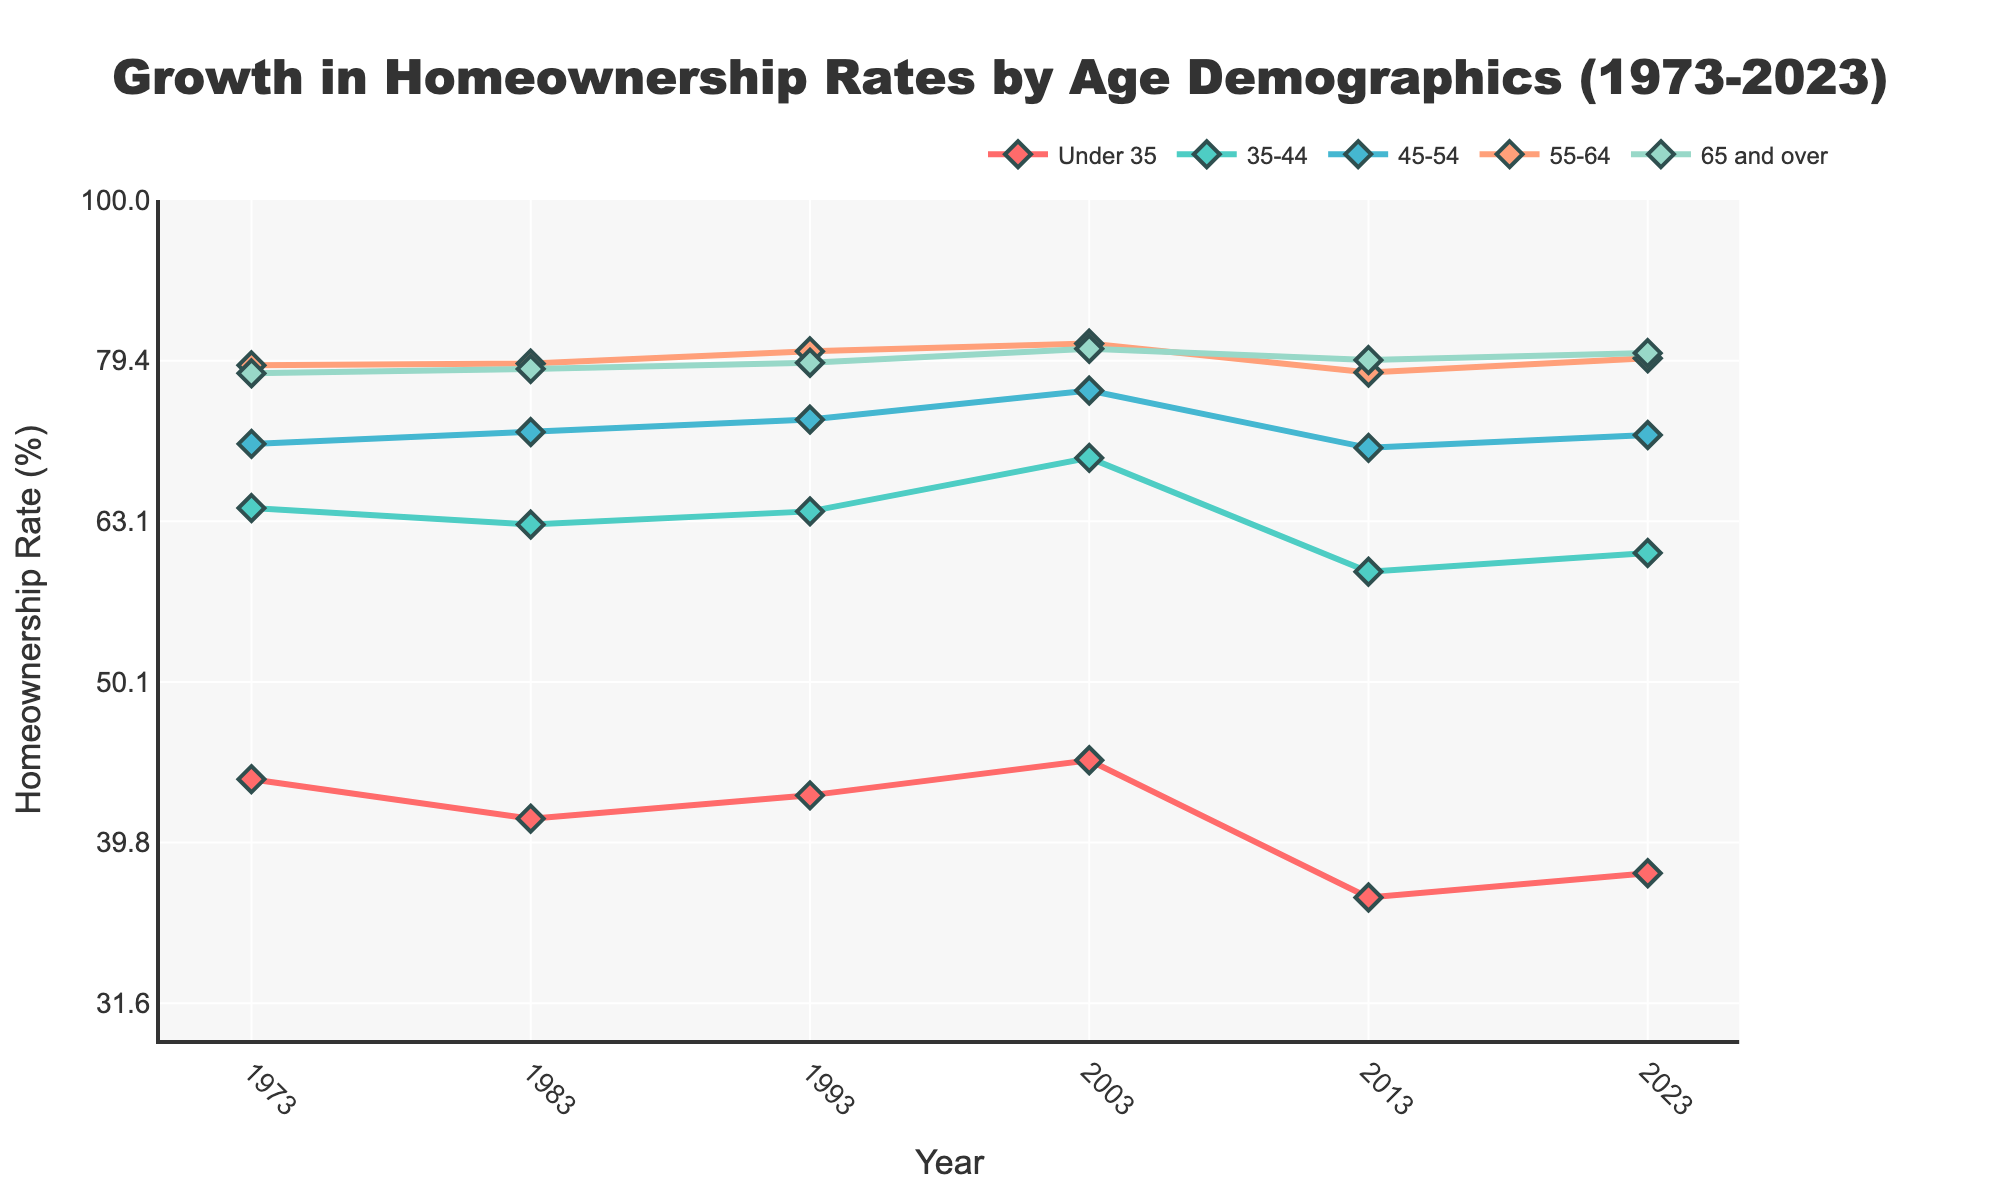what is the title of the plot? The title of the plot is displayed at the top of the figure in a larger font. It summarizes the content and purpose of the figure.
Answer: Growth in Homeownership Rates by Age Demographics (1973-2023) what are the age demographics represented in the plot? The age demographics are labeled in the legend and along the plot lines. They include various age ranges depicted with different colors and markers.
Answer: Under 35, 35-44, 45-54, 55-64, 65 and over how does the homeownership rate for the 35-44 age group in 1973 compare to 2023? To compare the homeownership rates for the 35-44 age group between 1973 and 2023, observe the endpoints of the line representing the 35-44 age group on the plot. Note the corresponding values on the y-axis.
Answer: The rate increased from 64.3% (1973) to 60.3% (2023) which age demographic has the highest homeownership rate in 2023? To determine the age demographic with the highest homeownership rate in 2023, look at the rightmost endpoints of each line and compare their y-axis values.
Answer: 65 and over what trend is observed for the homeownership rate of the under 35 age group from 1973 to 2023? To observe the trend, look at the behavior of the line corresponding to the under 35 age group across the years shown on the x-axis. Notice whether the line generally increases, decreases, or fluctuates.
Answer: The rate fluctuated, with an overall decline for which age group is the fluctuation in homeownership rate the most noticeable over the 50 years? To identify the age group with the most noticeable fluctuations, compare the variations in the y-values for each age group's line across the entire x-axis range.
Answer: 35-44 exhibits noticeable fluctuations calculate the average homeownership rate for the 45-54 age group from 1973 to 2023. To calculate the average, add the homeownership rates for the 45-54 age group for all years and divide by the number of data points (years).
Answer: (70.5 + 71.7 + 73.0 + 76.1 + 70.1 + 71.4) / 6 = 72.1 describe the change in homeownership rate for the 55-64 age group between 2003 and 2013. To describe the change, observe the y-values of the 55-64 age group's line for the years 2003 and 2013, then calculate the difference in rates.
Answer: The rate decreased from 81.4% to 78.1% what was the maximum homeownership rate achieved by any age group over the 50-year span? To find the maximum rate achieved, scan all the y-values across all age group lines and years, then identify the highest value.
Answer: 81.4% by the 55-64 age group in 2003 